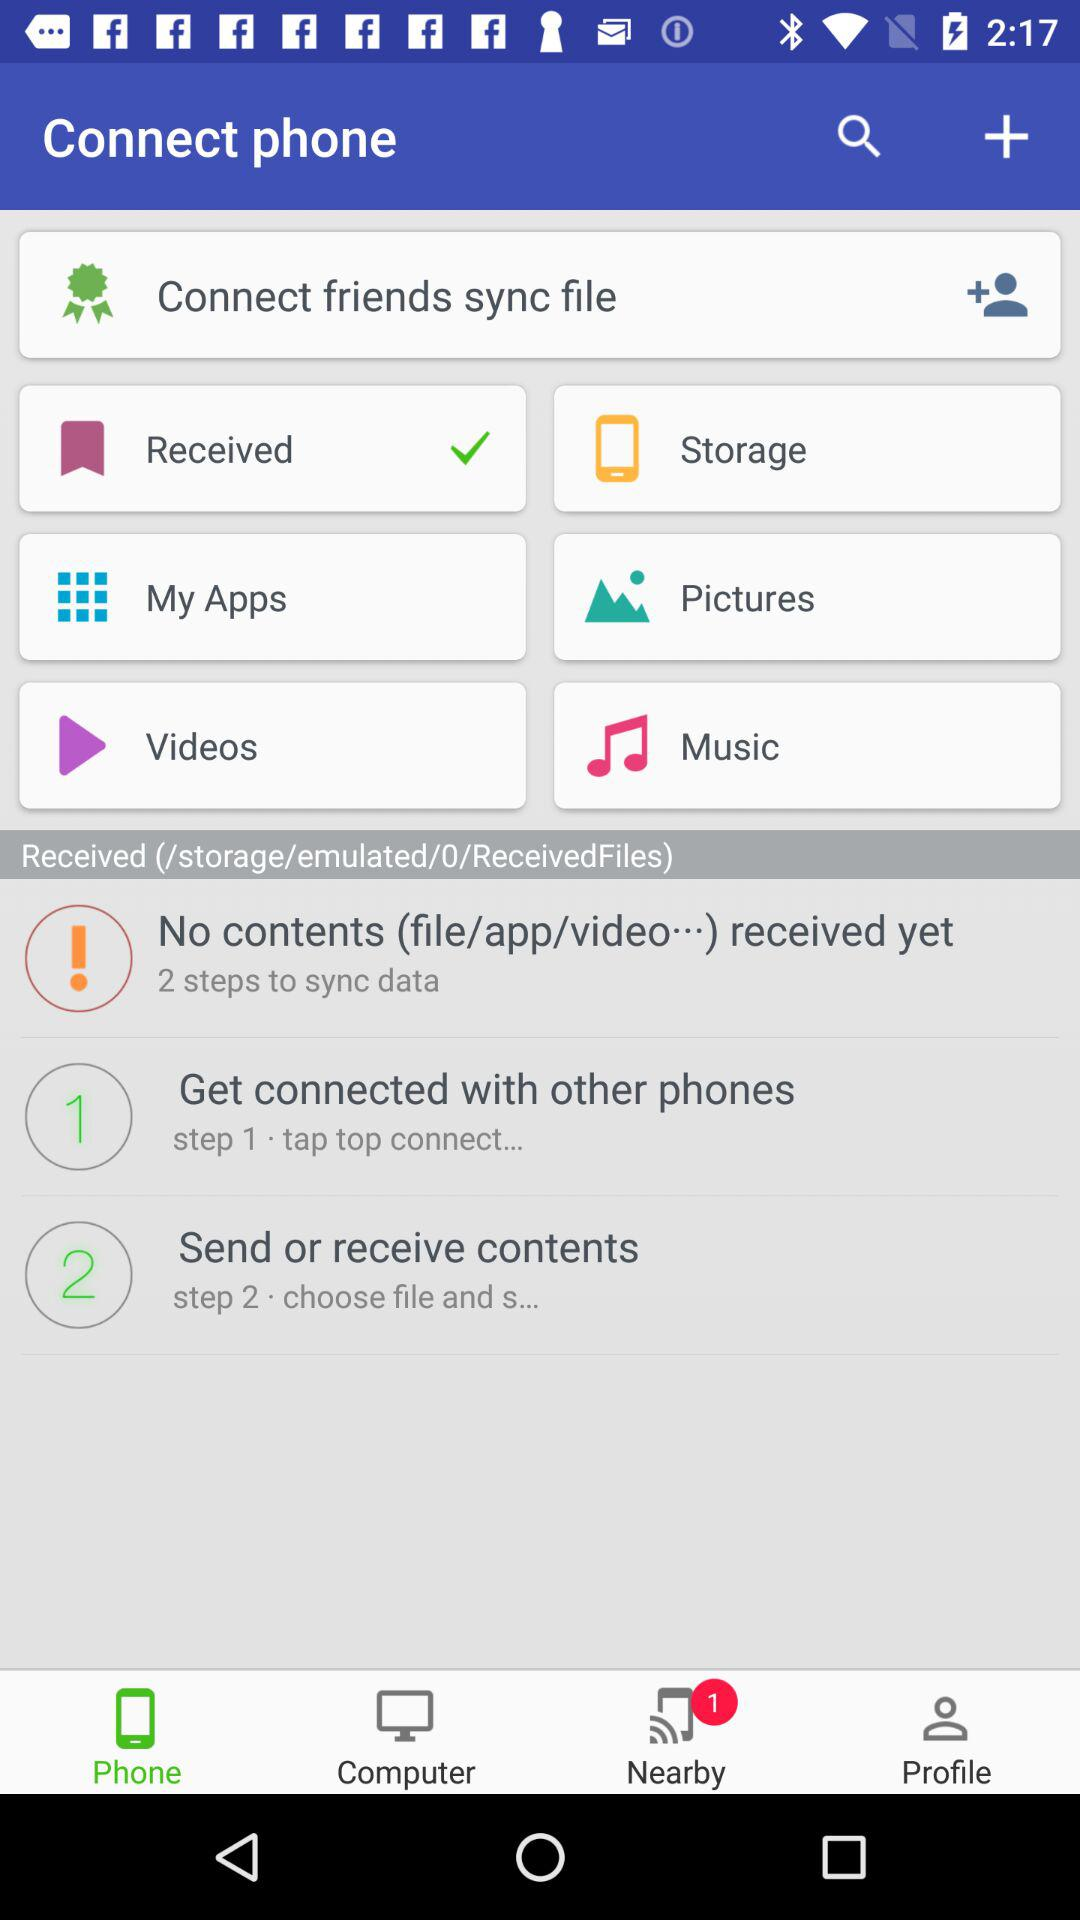How many steps are there in the syncing process?
Answer the question using a single word or phrase. 2 